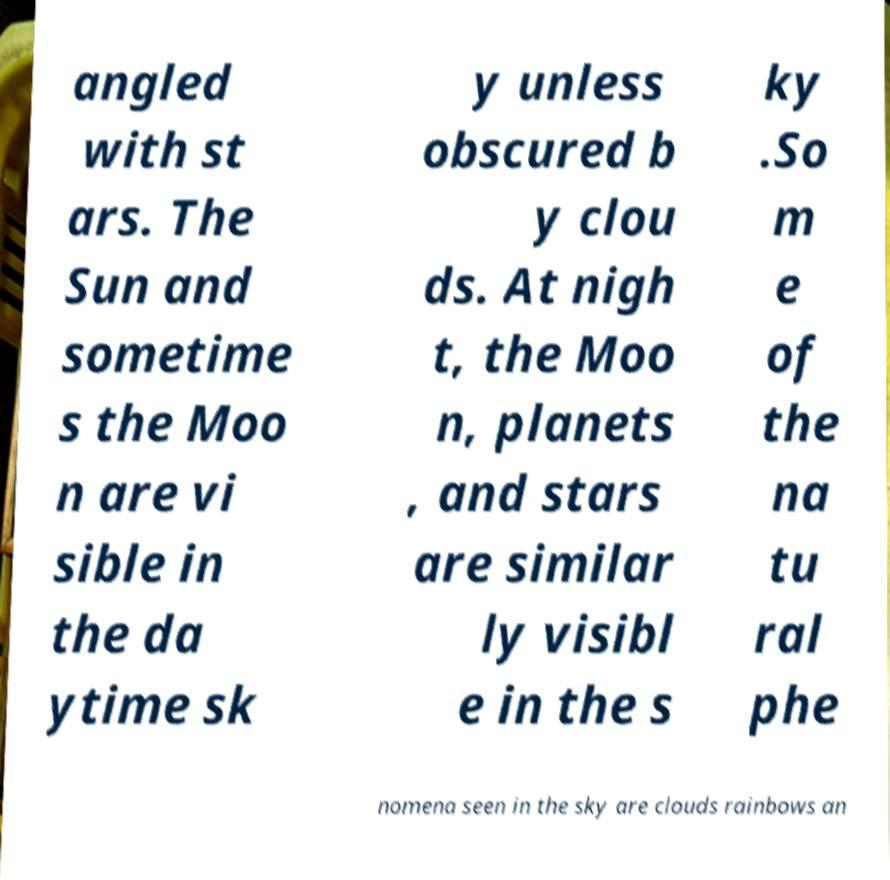Can you read and provide the text displayed in the image?This photo seems to have some interesting text. Can you extract and type it out for me? angled with st ars. The Sun and sometime s the Moo n are vi sible in the da ytime sk y unless obscured b y clou ds. At nigh t, the Moo n, planets , and stars are similar ly visibl e in the s ky .So m e of the na tu ral phe nomena seen in the sky are clouds rainbows an 